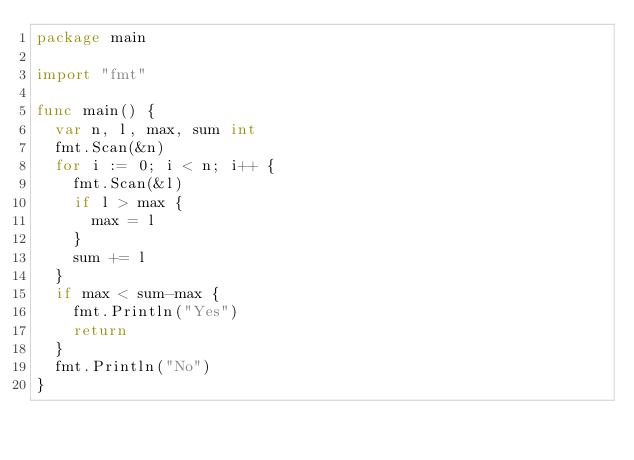<code> <loc_0><loc_0><loc_500><loc_500><_Go_>package main

import "fmt"

func main() {
	var n, l, max, sum int
	fmt.Scan(&n)
	for i := 0; i < n; i++ {
		fmt.Scan(&l)
		if l > max {
			max = l
		}
		sum += l
	}
	if max < sum-max {
		fmt.Println("Yes")
		return
	}
	fmt.Println("No")
}
</code> 